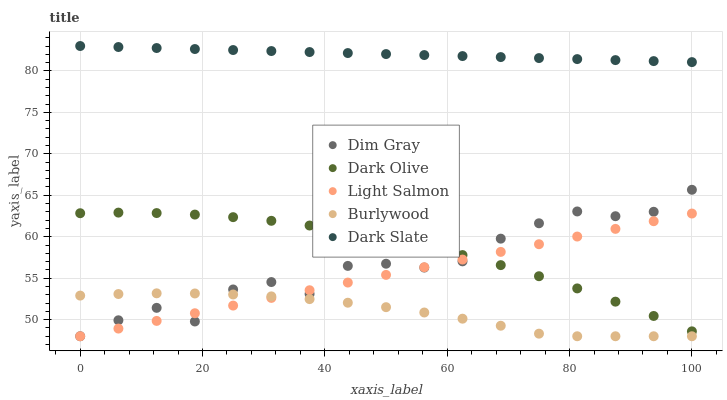Does Burlywood have the minimum area under the curve?
Answer yes or no. Yes. Does Dark Slate have the maximum area under the curve?
Answer yes or no. Yes. Does Light Salmon have the minimum area under the curve?
Answer yes or no. No. Does Light Salmon have the maximum area under the curve?
Answer yes or no. No. Is Light Salmon the smoothest?
Answer yes or no. Yes. Is Dim Gray the roughest?
Answer yes or no. Yes. Is Burlywood the smoothest?
Answer yes or no. No. Is Burlywood the roughest?
Answer yes or no. No. Does Burlywood have the lowest value?
Answer yes or no. Yes. Does Dark Slate have the lowest value?
Answer yes or no. No. Does Dark Slate have the highest value?
Answer yes or no. Yes. Does Light Salmon have the highest value?
Answer yes or no. No. Is Dim Gray less than Dark Slate?
Answer yes or no. Yes. Is Dark Slate greater than Dark Olive?
Answer yes or no. Yes. Does Dark Olive intersect Dim Gray?
Answer yes or no. Yes. Is Dark Olive less than Dim Gray?
Answer yes or no. No. Is Dark Olive greater than Dim Gray?
Answer yes or no. No. Does Dim Gray intersect Dark Slate?
Answer yes or no. No. 